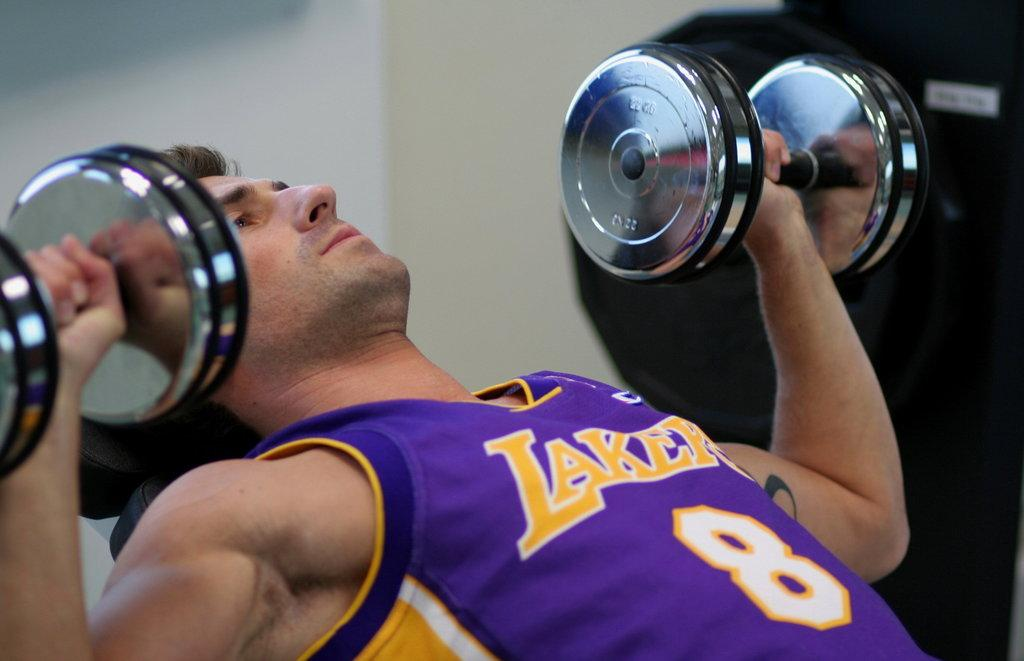<image>
Give a short and clear explanation of the subsequent image. a person lifting weights with a Lakers jersey on 